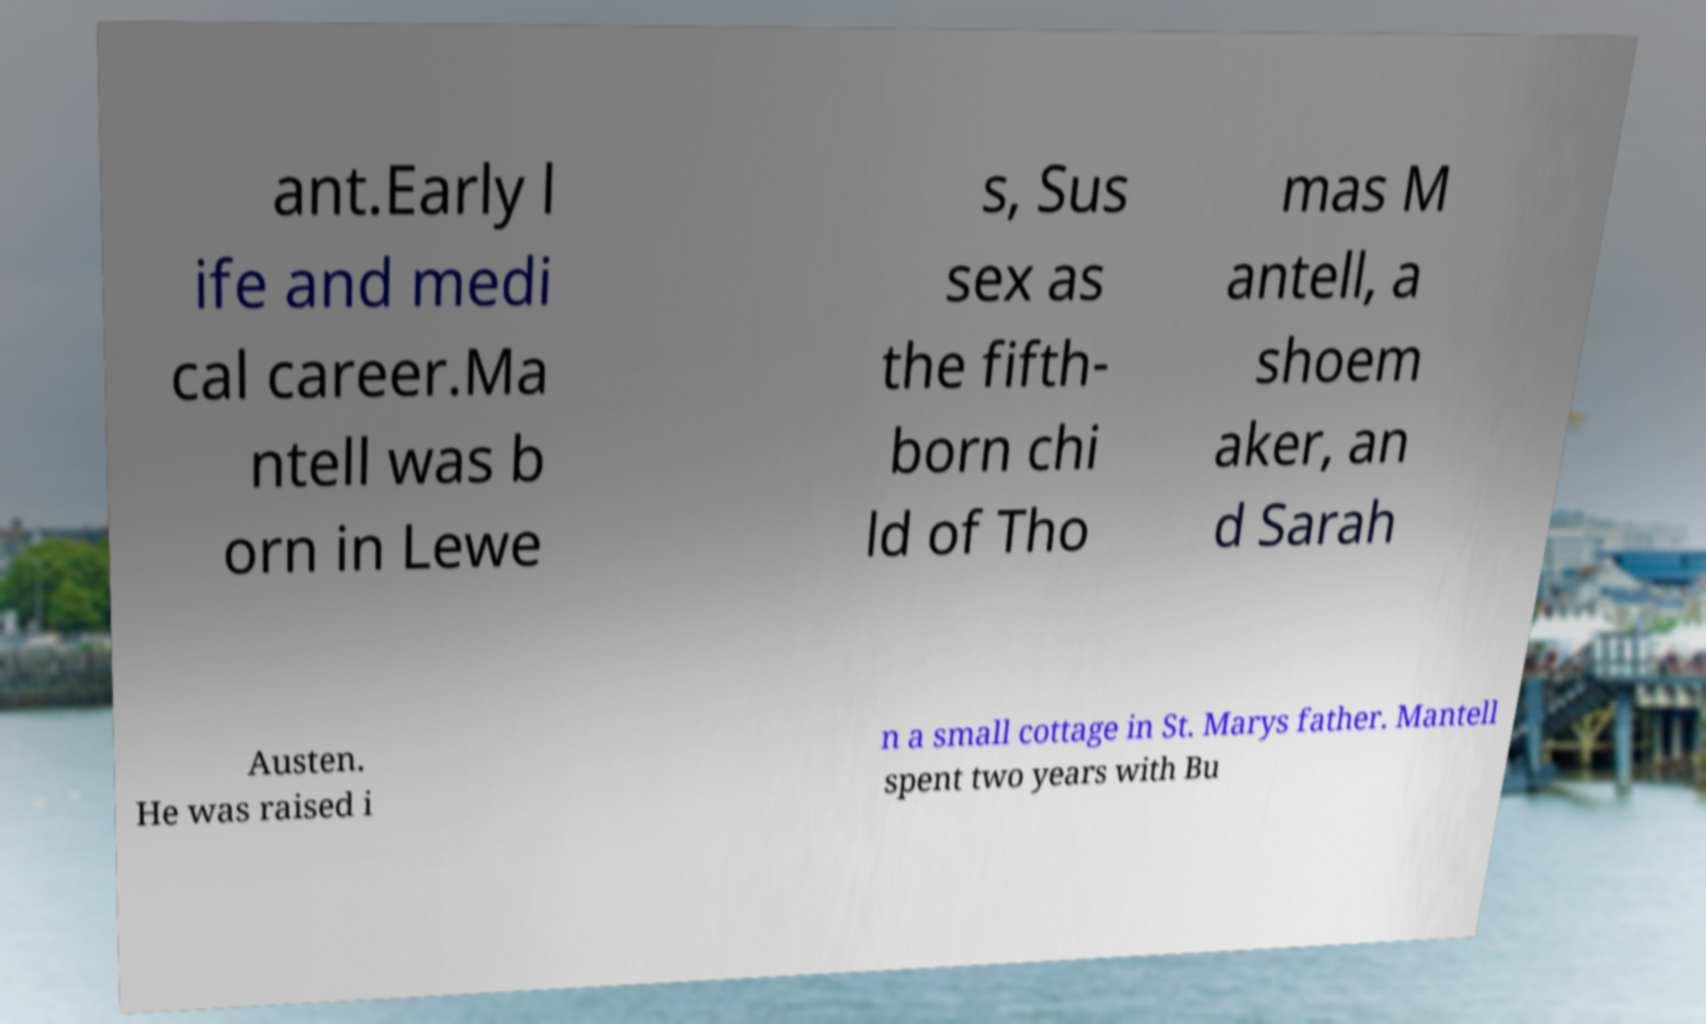Please read and relay the text visible in this image. What does it say? ant.Early l ife and medi cal career.Ma ntell was b orn in Lewe s, Sus sex as the fifth- born chi ld of Tho mas M antell, a shoem aker, an d Sarah Austen. He was raised i n a small cottage in St. Marys father. Mantell spent two years with Bu 